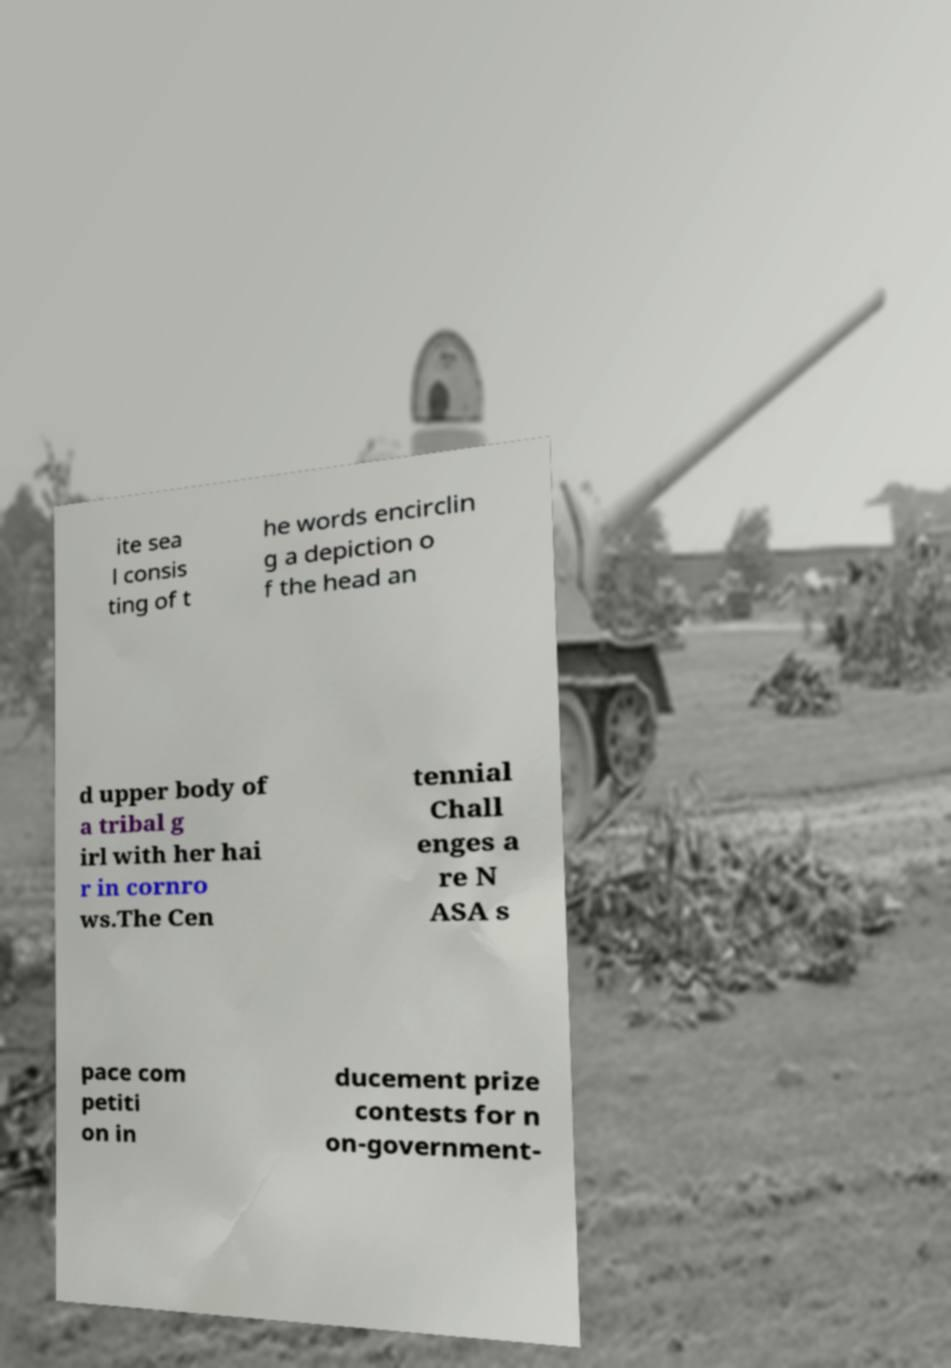Can you accurately transcribe the text from the provided image for me? ite sea l consis ting of t he words encirclin g a depiction o f the head an d upper body of a tribal g irl with her hai r in cornro ws.The Cen tennial Chall enges a re N ASA s pace com petiti on in ducement prize contests for n on-government- 